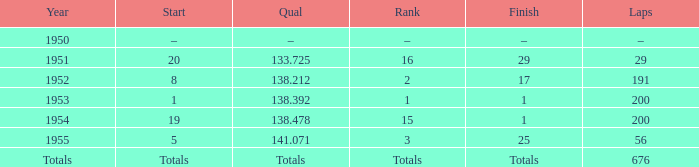Which finish achieved a qualification at 141.071? 25.0. 